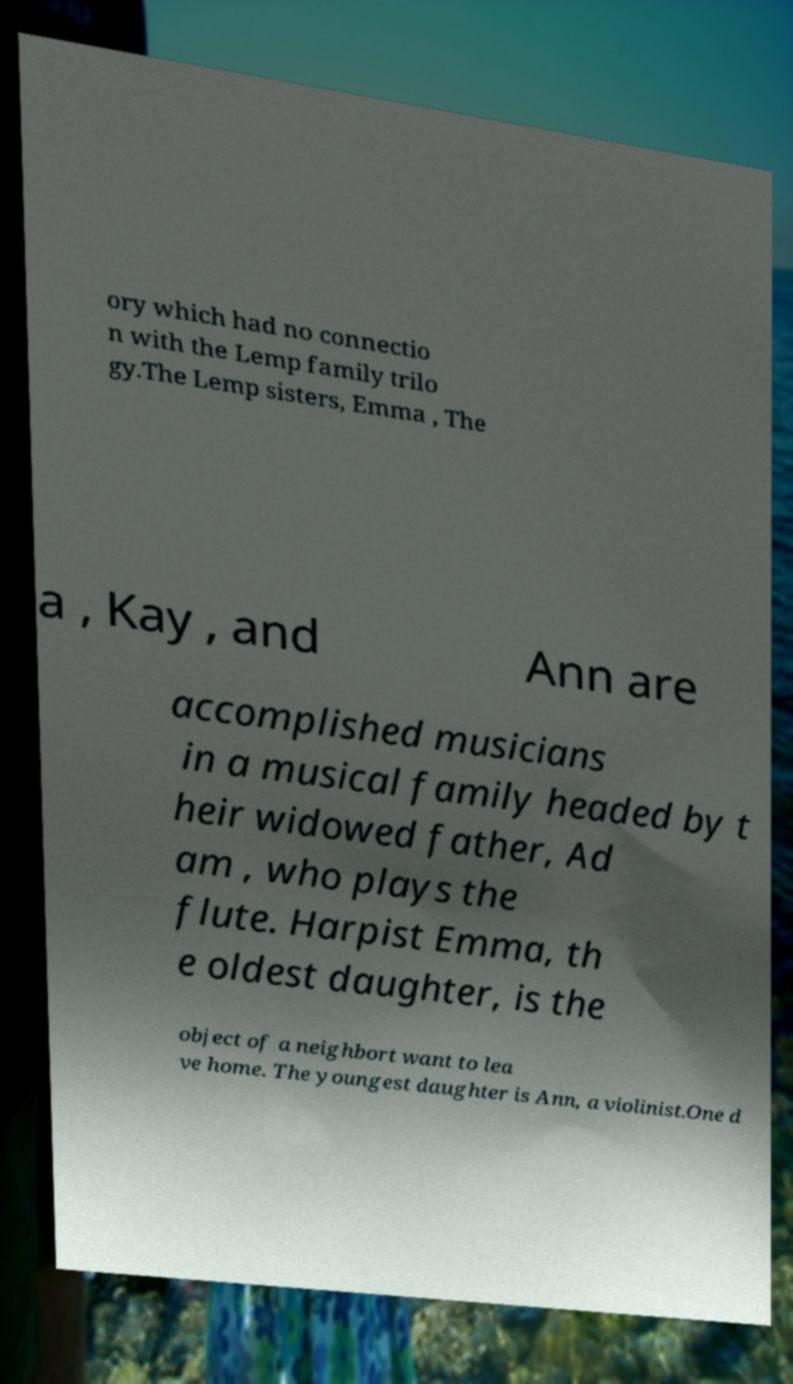What messages or text are displayed in this image? I need them in a readable, typed format. ory which had no connectio n with the Lemp family trilo gy.The Lemp sisters, Emma , The a , Kay , and Ann are accomplished musicians in a musical family headed by t heir widowed father, Ad am , who plays the flute. Harpist Emma, th e oldest daughter, is the object of a neighbort want to lea ve home. The youngest daughter is Ann, a violinist.One d 